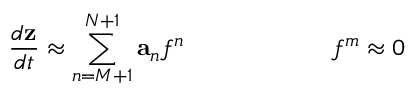<formula> <loc_0><loc_0><loc_500><loc_500>\, \frac { d z } { d t } \approx \sum _ { n = M + 1 } ^ { N + 1 } a _ { n } f ^ { n } \quad f ^ { m } \approx 0</formula> 